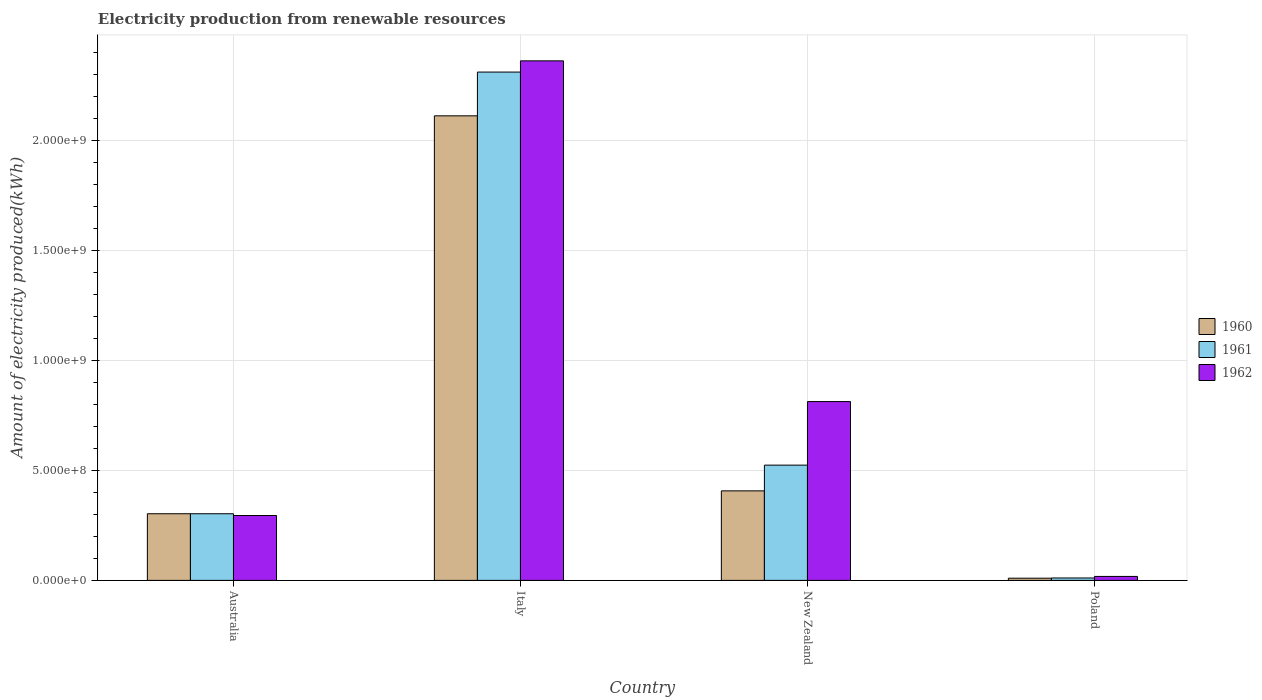Are the number of bars on each tick of the X-axis equal?
Make the answer very short. Yes. How many bars are there on the 2nd tick from the left?
Keep it short and to the point. 3. What is the amount of electricity produced in 1960 in Australia?
Your answer should be very brief. 3.03e+08. Across all countries, what is the maximum amount of electricity produced in 1962?
Make the answer very short. 2.36e+09. Across all countries, what is the minimum amount of electricity produced in 1960?
Provide a succinct answer. 1.00e+07. In which country was the amount of electricity produced in 1960 minimum?
Give a very brief answer. Poland. What is the total amount of electricity produced in 1960 in the graph?
Ensure brevity in your answer.  2.83e+09. What is the difference between the amount of electricity produced in 1962 in Italy and that in Poland?
Make the answer very short. 2.34e+09. What is the difference between the amount of electricity produced in 1960 in New Zealand and the amount of electricity produced in 1962 in Australia?
Provide a succinct answer. 1.12e+08. What is the average amount of electricity produced in 1962 per country?
Your answer should be compact. 8.72e+08. What is the difference between the amount of electricity produced of/in 1960 and amount of electricity produced of/in 1962 in Poland?
Provide a succinct answer. -8.00e+06. What is the ratio of the amount of electricity produced in 1962 in New Zealand to that in Poland?
Provide a succinct answer. 45.17. Is the amount of electricity produced in 1960 in Australia less than that in New Zealand?
Make the answer very short. Yes. Is the difference between the amount of electricity produced in 1960 in Australia and New Zealand greater than the difference between the amount of electricity produced in 1962 in Australia and New Zealand?
Keep it short and to the point. Yes. What is the difference between the highest and the second highest amount of electricity produced in 1961?
Make the answer very short. 1.79e+09. What is the difference between the highest and the lowest amount of electricity produced in 1962?
Offer a terse response. 2.34e+09. Is the sum of the amount of electricity produced in 1962 in Italy and Poland greater than the maximum amount of electricity produced in 1960 across all countries?
Give a very brief answer. Yes. What does the 2nd bar from the left in Australia represents?
Provide a succinct answer. 1961. How many bars are there?
Your response must be concise. 12. Are all the bars in the graph horizontal?
Give a very brief answer. No. Are the values on the major ticks of Y-axis written in scientific E-notation?
Provide a succinct answer. Yes. Does the graph contain any zero values?
Provide a short and direct response. No. How many legend labels are there?
Offer a very short reply. 3. What is the title of the graph?
Give a very brief answer. Electricity production from renewable resources. Does "1964" appear as one of the legend labels in the graph?
Provide a succinct answer. No. What is the label or title of the Y-axis?
Your response must be concise. Amount of electricity produced(kWh). What is the Amount of electricity produced(kWh) in 1960 in Australia?
Provide a short and direct response. 3.03e+08. What is the Amount of electricity produced(kWh) in 1961 in Australia?
Your answer should be very brief. 3.03e+08. What is the Amount of electricity produced(kWh) in 1962 in Australia?
Your answer should be very brief. 2.95e+08. What is the Amount of electricity produced(kWh) in 1960 in Italy?
Your answer should be compact. 2.11e+09. What is the Amount of electricity produced(kWh) in 1961 in Italy?
Provide a succinct answer. 2.31e+09. What is the Amount of electricity produced(kWh) of 1962 in Italy?
Provide a short and direct response. 2.36e+09. What is the Amount of electricity produced(kWh) of 1960 in New Zealand?
Offer a terse response. 4.07e+08. What is the Amount of electricity produced(kWh) of 1961 in New Zealand?
Your answer should be compact. 5.24e+08. What is the Amount of electricity produced(kWh) of 1962 in New Zealand?
Your answer should be very brief. 8.13e+08. What is the Amount of electricity produced(kWh) of 1960 in Poland?
Provide a succinct answer. 1.00e+07. What is the Amount of electricity produced(kWh) in 1961 in Poland?
Your response must be concise. 1.10e+07. What is the Amount of electricity produced(kWh) in 1962 in Poland?
Give a very brief answer. 1.80e+07. Across all countries, what is the maximum Amount of electricity produced(kWh) in 1960?
Keep it short and to the point. 2.11e+09. Across all countries, what is the maximum Amount of electricity produced(kWh) in 1961?
Your answer should be very brief. 2.31e+09. Across all countries, what is the maximum Amount of electricity produced(kWh) of 1962?
Provide a succinct answer. 2.36e+09. Across all countries, what is the minimum Amount of electricity produced(kWh) of 1960?
Keep it short and to the point. 1.00e+07. Across all countries, what is the minimum Amount of electricity produced(kWh) in 1961?
Offer a terse response. 1.10e+07. Across all countries, what is the minimum Amount of electricity produced(kWh) of 1962?
Ensure brevity in your answer.  1.80e+07. What is the total Amount of electricity produced(kWh) in 1960 in the graph?
Give a very brief answer. 2.83e+09. What is the total Amount of electricity produced(kWh) of 1961 in the graph?
Offer a terse response. 3.15e+09. What is the total Amount of electricity produced(kWh) of 1962 in the graph?
Offer a terse response. 3.49e+09. What is the difference between the Amount of electricity produced(kWh) of 1960 in Australia and that in Italy?
Offer a very short reply. -1.81e+09. What is the difference between the Amount of electricity produced(kWh) of 1961 in Australia and that in Italy?
Provide a succinct answer. -2.01e+09. What is the difference between the Amount of electricity produced(kWh) in 1962 in Australia and that in Italy?
Keep it short and to the point. -2.07e+09. What is the difference between the Amount of electricity produced(kWh) in 1960 in Australia and that in New Zealand?
Offer a very short reply. -1.04e+08. What is the difference between the Amount of electricity produced(kWh) of 1961 in Australia and that in New Zealand?
Your response must be concise. -2.21e+08. What is the difference between the Amount of electricity produced(kWh) in 1962 in Australia and that in New Zealand?
Give a very brief answer. -5.18e+08. What is the difference between the Amount of electricity produced(kWh) of 1960 in Australia and that in Poland?
Keep it short and to the point. 2.93e+08. What is the difference between the Amount of electricity produced(kWh) in 1961 in Australia and that in Poland?
Your response must be concise. 2.92e+08. What is the difference between the Amount of electricity produced(kWh) in 1962 in Australia and that in Poland?
Give a very brief answer. 2.77e+08. What is the difference between the Amount of electricity produced(kWh) of 1960 in Italy and that in New Zealand?
Give a very brief answer. 1.70e+09. What is the difference between the Amount of electricity produced(kWh) of 1961 in Italy and that in New Zealand?
Provide a succinct answer. 1.79e+09. What is the difference between the Amount of electricity produced(kWh) of 1962 in Italy and that in New Zealand?
Give a very brief answer. 1.55e+09. What is the difference between the Amount of electricity produced(kWh) of 1960 in Italy and that in Poland?
Make the answer very short. 2.10e+09. What is the difference between the Amount of electricity produced(kWh) of 1961 in Italy and that in Poland?
Offer a terse response. 2.30e+09. What is the difference between the Amount of electricity produced(kWh) in 1962 in Italy and that in Poland?
Provide a short and direct response. 2.34e+09. What is the difference between the Amount of electricity produced(kWh) of 1960 in New Zealand and that in Poland?
Offer a terse response. 3.97e+08. What is the difference between the Amount of electricity produced(kWh) of 1961 in New Zealand and that in Poland?
Make the answer very short. 5.13e+08. What is the difference between the Amount of electricity produced(kWh) in 1962 in New Zealand and that in Poland?
Provide a short and direct response. 7.95e+08. What is the difference between the Amount of electricity produced(kWh) of 1960 in Australia and the Amount of electricity produced(kWh) of 1961 in Italy?
Offer a very short reply. -2.01e+09. What is the difference between the Amount of electricity produced(kWh) in 1960 in Australia and the Amount of electricity produced(kWh) in 1962 in Italy?
Make the answer very short. -2.06e+09. What is the difference between the Amount of electricity produced(kWh) in 1961 in Australia and the Amount of electricity produced(kWh) in 1962 in Italy?
Provide a succinct answer. -2.06e+09. What is the difference between the Amount of electricity produced(kWh) in 1960 in Australia and the Amount of electricity produced(kWh) in 1961 in New Zealand?
Make the answer very short. -2.21e+08. What is the difference between the Amount of electricity produced(kWh) of 1960 in Australia and the Amount of electricity produced(kWh) of 1962 in New Zealand?
Offer a very short reply. -5.10e+08. What is the difference between the Amount of electricity produced(kWh) of 1961 in Australia and the Amount of electricity produced(kWh) of 1962 in New Zealand?
Make the answer very short. -5.10e+08. What is the difference between the Amount of electricity produced(kWh) of 1960 in Australia and the Amount of electricity produced(kWh) of 1961 in Poland?
Offer a very short reply. 2.92e+08. What is the difference between the Amount of electricity produced(kWh) in 1960 in Australia and the Amount of electricity produced(kWh) in 1962 in Poland?
Provide a succinct answer. 2.85e+08. What is the difference between the Amount of electricity produced(kWh) of 1961 in Australia and the Amount of electricity produced(kWh) of 1962 in Poland?
Ensure brevity in your answer.  2.85e+08. What is the difference between the Amount of electricity produced(kWh) in 1960 in Italy and the Amount of electricity produced(kWh) in 1961 in New Zealand?
Give a very brief answer. 1.59e+09. What is the difference between the Amount of electricity produced(kWh) of 1960 in Italy and the Amount of electricity produced(kWh) of 1962 in New Zealand?
Provide a succinct answer. 1.30e+09. What is the difference between the Amount of electricity produced(kWh) in 1961 in Italy and the Amount of electricity produced(kWh) in 1962 in New Zealand?
Make the answer very short. 1.50e+09. What is the difference between the Amount of electricity produced(kWh) in 1960 in Italy and the Amount of electricity produced(kWh) in 1961 in Poland?
Give a very brief answer. 2.10e+09. What is the difference between the Amount of electricity produced(kWh) in 1960 in Italy and the Amount of electricity produced(kWh) in 1962 in Poland?
Provide a short and direct response. 2.09e+09. What is the difference between the Amount of electricity produced(kWh) in 1961 in Italy and the Amount of electricity produced(kWh) in 1962 in Poland?
Offer a terse response. 2.29e+09. What is the difference between the Amount of electricity produced(kWh) of 1960 in New Zealand and the Amount of electricity produced(kWh) of 1961 in Poland?
Your answer should be compact. 3.96e+08. What is the difference between the Amount of electricity produced(kWh) of 1960 in New Zealand and the Amount of electricity produced(kWh) of 1962 in Poland?
Your answer should be compact. 3.89e+08. What is the difference between the Amount of electricity produced(kWh) of 1961 in New Zealand and the Amount of electricity produced(kWh) of 1962 in Poland?
Your response must be concise. 5.06e+08. What is the average Amount of electricity produced(kWh) in 1960 per country?
Ensure brevity in your answer.  7.08e+08. What is the average Amount of electricity produced(kWh) of 1961 per country?
Your response must be concise. 7.87e+08. What is the average Amount of electricity produced(kWh) in 1962 per country?
Your answer should be very brief. 8.72e+08. What is the difference between the Amount of electricity produced(kWh) of 1960 and Amount of electricity produced(kWh) of 1961 in Australia?
Your response must be concise. 0. What is the difference between the Amount of electricity produced(kWh) of 1960 and Amount of electricity produced(kWh) of 1961 in Italy?
Ensure brevity in your answer.  -1.99e+08. What is the difference between the Amount of electricity produced(kWh) in 1960 and Amount of electricity produced(kWh) in 1962 in Italy?
Offer a terse response. -2.50e+08. What is the difference between the Amount of electricity produced(kWh) of 1961 and Amount of electricity produced(kWh) of 1962 in Italy?
Your answer should be compact. -5.10e+07. What is the difference between the Amount of electricity produced(kWh) of 1960 and Amount of electricity produced(kWh) of 1961 in New Zealand?
Offer a terse response. -1.17e+08. What is the difference between the Amount of electricity produced(kWh) of 1960 and Amount of electricity produced(kWh) of 1962 in New Zealand?
Provide a succinct answer. -4.06e+08. What is the difference between the Amount of electricity produced(kWh) in 1961 and Amount of electricity produced(kWh) in 1962 in New Zealand?
Keep it short and to the point. -2.89e+08. What is the difference between the Amount of electricity produced(kWh) in 1960 and Amount of electricity produced(kWh) in 1962 in Poland?
Make the answer very short. -8.00e+06. What is the difference between the Amount of electricity produced(kWh) of 1961 and Amount of electricity produced(kWh) of 1962 in Poland?
Your answer should be compact. -7.00e+06. What is the ratio of the Amount of electricity produced(kWh) in 1960 in Australia to that in Italy?
Give a very brief answer. 0.14. What is the ratio of the Amount of electricity produced(kWh) of 1961 in Australia to that in Italy?
Ensure brevity in your answer.  0.13. What is the ratio of the Amount of electricity produced(kWh) in 1962 in Australia to that in Italy?
Your answer should be very brief. 0.12. What is the ratio of the Amount of electricity produced(kWh) of 1960 in Australia to that in New Zealand?
Provide a short and direct response. 0.74. What is the ratio of the Amount of electricity produced(kWh) in 1961 in Australia to that in New Zealand?
Your response must be concise. 0.58. What is the ratio of the Amount of electricity produced(kWh) in 1962 in Australia to that in New Zealand?
Your response must be concise. 0.36. What is the ratio of the Amount of electricity produced(kWh) in 1960 in Australia to that in Poland?
Give a very brief answer. 30.3. What is the ratio of the Amount of electricity produced(kWh) in 1961 in Australia to that in Poland?
Make the answer very short. 27.55. What is the ratio of the Amount of electricity produced(kWh) in 1962 in Australia to that in Poland?
Offer a very short reply. 16.39. What is the ratio of the Amount of electricity produced(kWh) in 1960 in Italy to that in New Zealand?
Give a very brief answer. 5.19. What is the ratio of the Amount of electricity produced(kWh) in 1961 in Italy to that in New Zealand?
Ensure brevity in your answer.  4.41. What is the ratio of the Amount of electricity produced(kWh) of 1962 in Italy to that in New Zealand?
Make the answer very short. 2.91. What is the ratio of the Amount of electricity produced(kWh) in 1960 in Italy to that in Poland?
Offer a very short reply. 211.2. What is the ratio of the Amount of electricity produced(kWh) of 1961 in Italy to that in Poland?
Provide a succinct answer. 210.09. What is the ratio of the Amount of electricity produced(kWh) of 1962 in Italy to that in Poland?
Your answer should be compact. 131.22. What is the ratio of the Amount of electricity produced(kWh) of 1960 in New Zealand to that in Poland?
Provide a succinct answer. 40.7. What is the ratio of the Amount of electricity produced(kWh) in 1961 in New Zealand to that in Poland?
Keep it short and to the point. 47.64. What is the ratio of the Amount of electricity produced(kWh) of 1962 in New Zealand to that in Poland?
Your answer should be very brief. 45.17. What is the difference between the highest and the second highest Amount of electricity produced(kWh) of 1960?
Ensure brevity in your answer.  1.70e+09. What is the difference between the highest and the second highest Amount of electricity produced(kWh) in 1961?
Your answer should be compact. 1.79e+09. What is the difference between the highest and the second highest Amount of electricity produced(kWh) of 1962?
Provide a succinct answer. 1.55e+09. What is the difference between the highest and the lowest Amount of electricity produced(kWh) of 1960?
Offer a very short reply. 2.10e+09. What is the difference between the highest and the lowest Amount of electricity produced(kWh) of 1961?
Offer a terse response. 2.30e+09. What is the difference between the highest and the lowest Amount of electricity produced(kWh) in 1962?
Offer a terse response. 2.34e+09. 